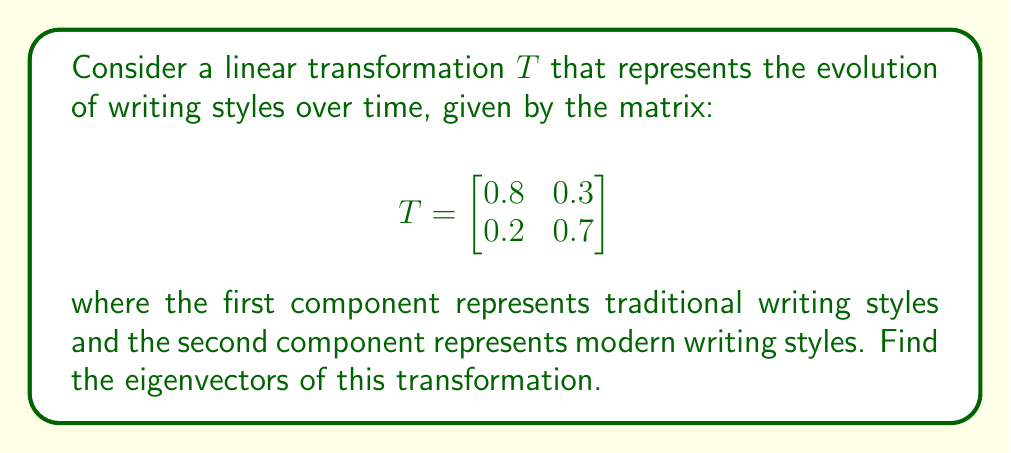Can you answer this question? To find the eigenvectors of the linear transformation $T$, we follow these steps:

1) First, we need to find the eigenvalues by solving the characteristic equation:

   $det(T - \lambda I) = 0$

   $$\begin{vmatrix}
   0.8 - \lambda & 0.3 \\
   0.2 & 0.7 - \lambda
   \end{vmatrix} = 0$$

2) Expanding the determinant:

   $(0.8 - \lambda)(0.7 - \lambda) - 0.3 \cdot 0.2 = 0$
   
   $\lambda^2 - 1.5\lambda + 0.5 = 0$

3) Solving this quadratic equation:

   $\lambda = \frac{1.5 \pm \sqrt{1.5^2 - 4(0.5)}}{2} = \frac{1.5 \pm \sqrt{1.25}}{2}$

   $\lambda_1 = 1$ and $\lambda_2 = 0.5$

4) Now, for each eigenvalue, we find the corresponding eigenvector by solving $(T - \lambda I)v = 0$:

   For $\lambda_1 = 1$:
   
   $$\begin{bmatrix}
   -0.2 & 0.3 \\
   0.2 & -0.3
   \end{bmatrix} \begin{bmatrix}
   v_1 \\
   v_2
   \end{bmatrix} = \begin{bmatrix}
   0 \\
   0
   \end{bmatrix}$$

   This gives us $v_2 = \frac{2}{3}v_1$. Let $v_1 = 3$, then $v_2 = 2$.

   For $\lambda_2 = 0.5$:
   
   $$\begin{bmatrix}
   0.3 & 0.3 \\
   0.2 & 0.2
   \end{bmatrix} \begin{bmatrix}
   v_1 \\
   v_2
   \end{bmatrix} = \begin{bmatrix}
   0 \\
   0
   \end{bmatrix}$$

   This gives us $v_2 = -v_1$. Let $v_1 = 1$, then $v_2 = -1$.

5) Therefore, the eigenvectors are:

   $v_1 = \begin{bmatrix} 3 \\ 2 \end{bmatrix}$ and $v_2 = \begin{bmatrix} 1 \\ -1 \end{bmatrix}$
Answer: $v_1 = \begin{bmatrix} 3 \\ 2 \end{bmatrix}, v_2 = \begin{bmatrix} 1 \\ -1 \end{bmatrix}$ 